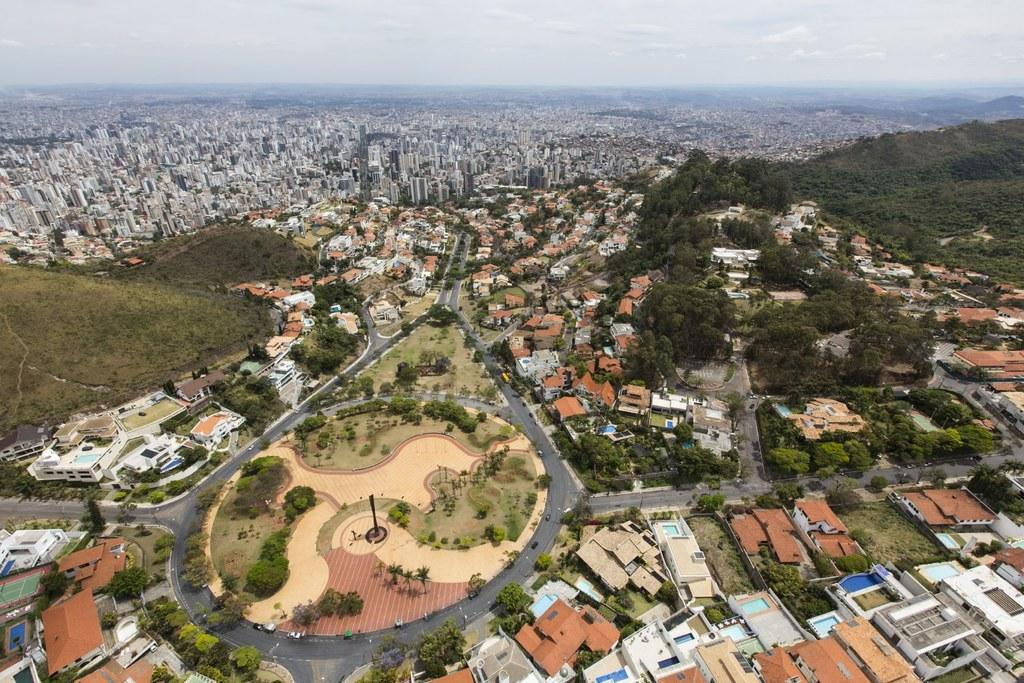What type of structures can be seen in the image? There are buildings in the image. What is present on the ground in the image? There is a road in the image. What is moving along the road in the image? There are vehicles on the road. What type of natural elements can be seen in the image? There are trees visible in the image. What is visible in the background of the image? The sky is visible in the background of the image. How many tickets are being distributed to the vehicles in the image? There is no mention of tickets or their distribution in the image. What type of seat is visible in the image? There are no seats visible in the image. 